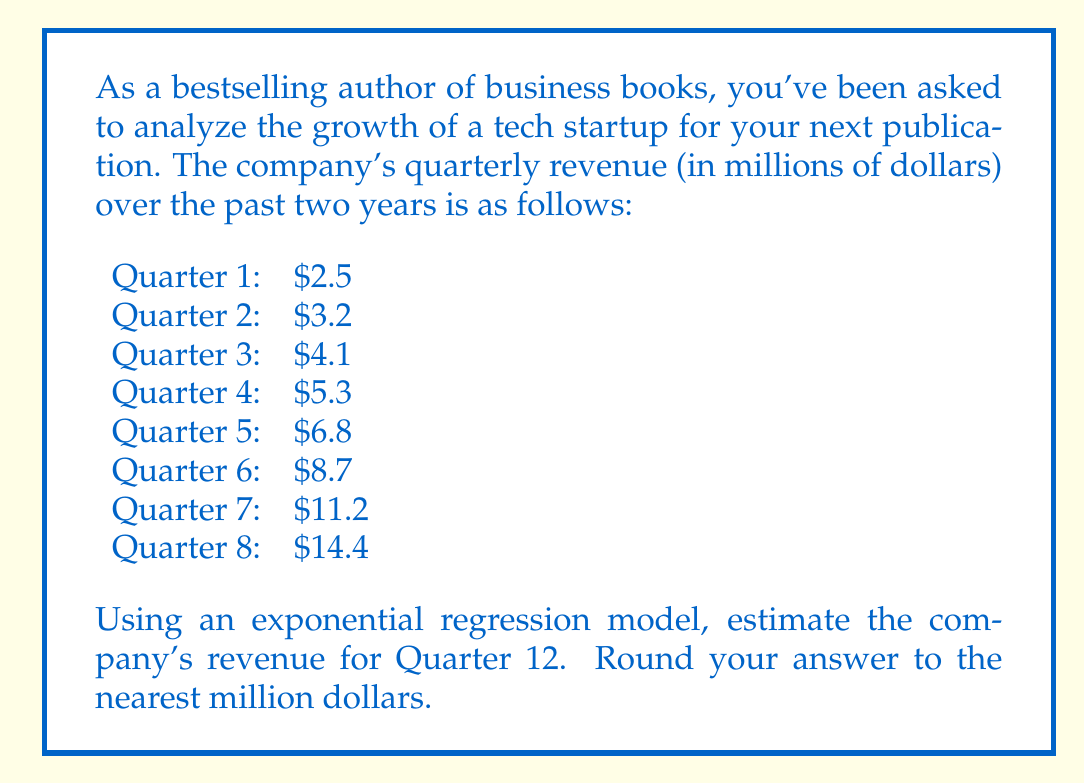Solve this math problem. To solve this problem, we'll use an exponential regression model of the form $y = ab^x$, where $y$ is the revenue, $x$ is the quarter number, and $a$ and $b$ are constants we need to determine.

Step 1: Transform the data to create a linear relationship.
Let $Y = \ln(y)$ and $X = x$. This transforms our model to $\ln(y) = \ln(a) + x\ln(b)$, which is linear in the form $Y = m X + c$.

Step 2: Calculate the necessary sums for the linear regression.
$$\sum X = 1 + 2 + 3 + 4 + 5 + 6 + 7 + 8 = 36$$
$$\sum Y = \ln(2.5) + \ln(3.2) + \ln(4.1) + \ln(5.3) + \ln(6.8) + \ln(8.7) + \ln(11.2) + \ln(14.4) = 15.8604$$
$$\sum X^2 = 1^2 + 2^2 + 3^2 + 4^2 + 5^2 + 6^2 + 7^2 + 8^2 = 204$$
$$\sum XY = 1\ln(2.5) + 2\ln(3.2) + 3\ln(4.1) + 4\ln(5.3) + 5\ln(6.8) + 6\ln(8.7) + 7\ln(11.2) + 8\ln(14.4) = 89.0917$$
$$n = 8$$ (number of data points)

Step 3: Calculate the slope (m) and y-intercept (c) of the linear regression.
$$m = \frac{n\sum XY - \sum X \sum Y}{n\sum X^2 - (\sum X)^2} = \frac{8(89.0917) - 36(15.8604)}{8(204) - 36^2} = 0.2825$$
$$c = \frac{\sum Y}{n} - m\frac{\sum X}{n} = \frac{15.8604}{8} - 0.2825\frac{36}{8} = 0.8392$$

Step 4: Convert back to the exponential model.
$$\ln(a) = c = 0.8392$$
$$a = e^{0.8392} = 2.3145$$
$$\ln(b) = m = 0.2825$$
$$b = e^{0.2825} = 1.3265$$

Our exponential regression model is: $y = 2.3145(1.3265)^x$

Step 5: Estimate the revenue for Quarter 12 by plugging in $x = 12$.
$$y = 2.3145(1.3265)^{12} = 30.8969$$

Step 6: Round to the nearest million dollars.
$30.8969 million ≈ 31 million dollars
Answer: $31 million 